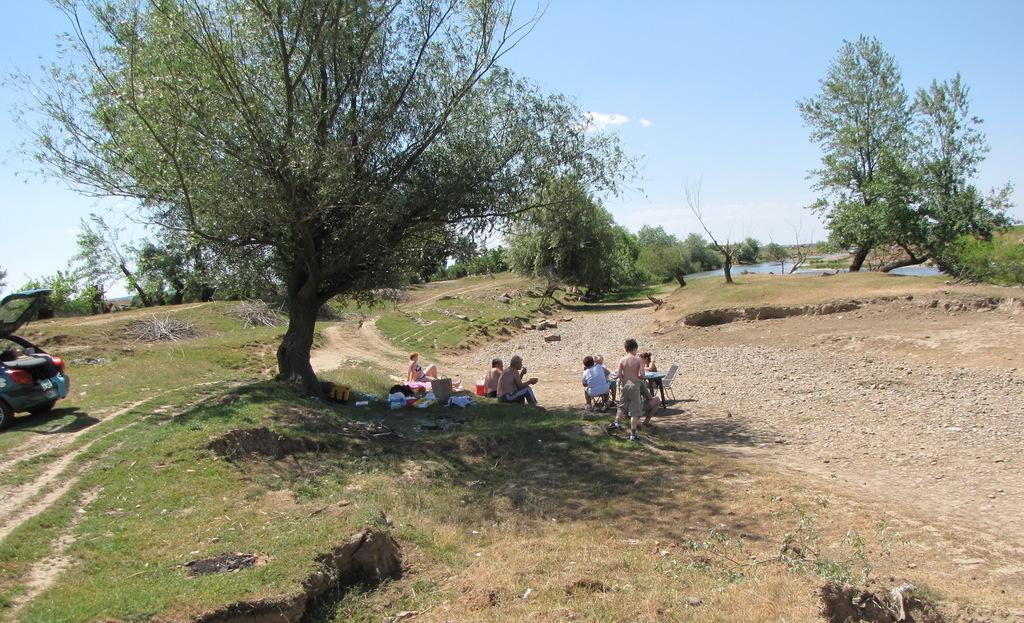Describe this image in one or two sentences. In this image in the center there are some people who are sitting, and in the foreground and background there are some trees. At the bottom there is sand and grass, and in the background there is one small pond. On the left side there is one car, on the top of the image there is sky. 